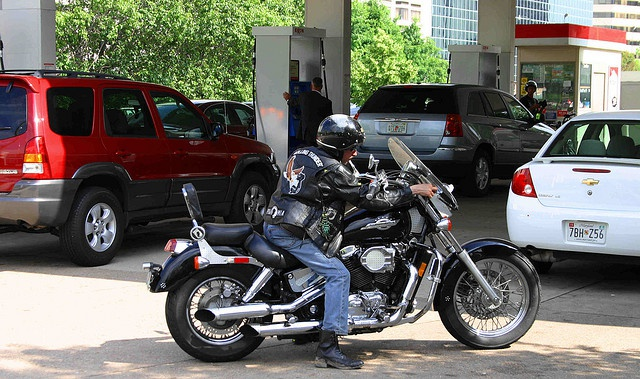Describe the objects in this image and their specific colors. I can see motorcycle in darkgray, black, gray, and white tones, car in darkgray, black, maroon, gray, and navy tones, car in darkgray, lavender, black, and lightblue tones, car in gray, black, and darkgray tones, and people in darkgray, black, and gray tones in this image. 